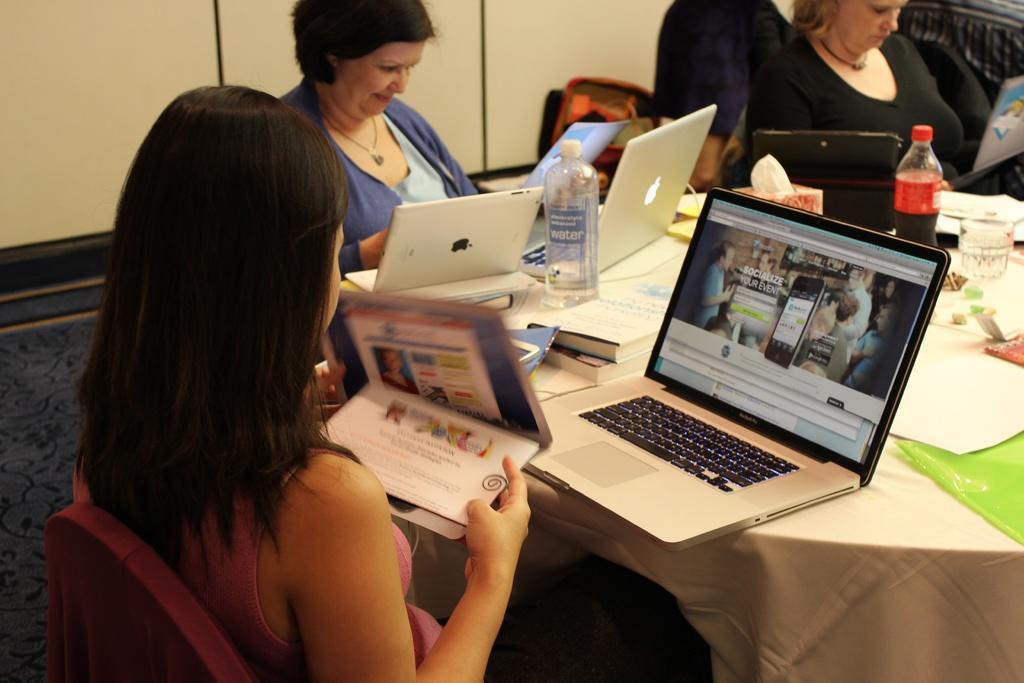In one or two sentences, can you explain what this image depicts? In this picture there is a table on the right side of the image, which contains laptops, papers, books, and a bottle, there are people those who are sitting around the table and there is a rug on the floor. 